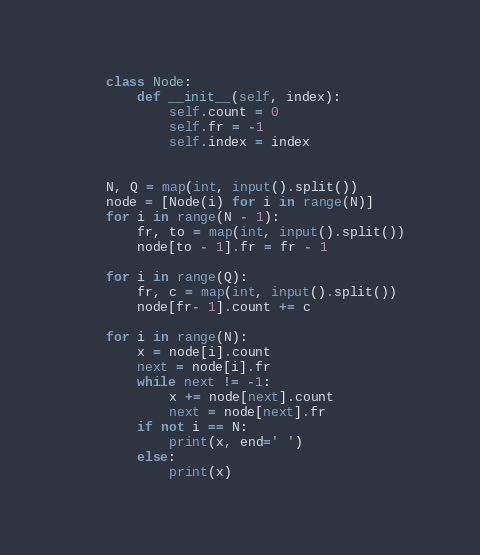<code> <loc_0><loc_0><loc_500><loc_500><_Python_>    class Node:
        def __init__(self, index):
            self.count = 0
            self.fr = -1
            self.index = index
     
     
    N, Q = map(int, input().split())
    node = [Node(i) for i in range(N)]
    for i in range(N - 1):
        fr, to = map(int, input().split())
        node[to - 1].fr = fr - 1
     
    for i in range(Q):
        fr, c = map(int, input().split())
        node[fr- 1].count += c
     
    for i in range(N):
        x = node[i].count
        next = node[i].fr
        while next != -1:
            x += node[next].count
            next = node[next].fr
        if not i == N:
            print(x, end=' ')
        else:
            print(x)</code> 